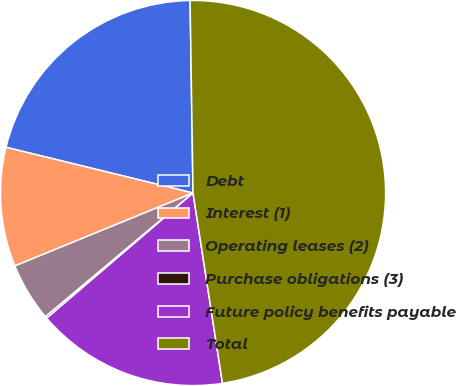<chart> <loc_0><loc_0><loc_500><loc_500><pie_chart><fcel>Debt<fcel>Interest (1)<fcel>Operating leases (2)<fcel>Purchase obligations (3)<fcel>Future policy benefits payable<fcel>Total<nl><fcel>20.94%<fcel>10.0%<fcel>4.92%<fcel>0.16%<fcel>16.18%<fcel>47.8%<nl></chart> 